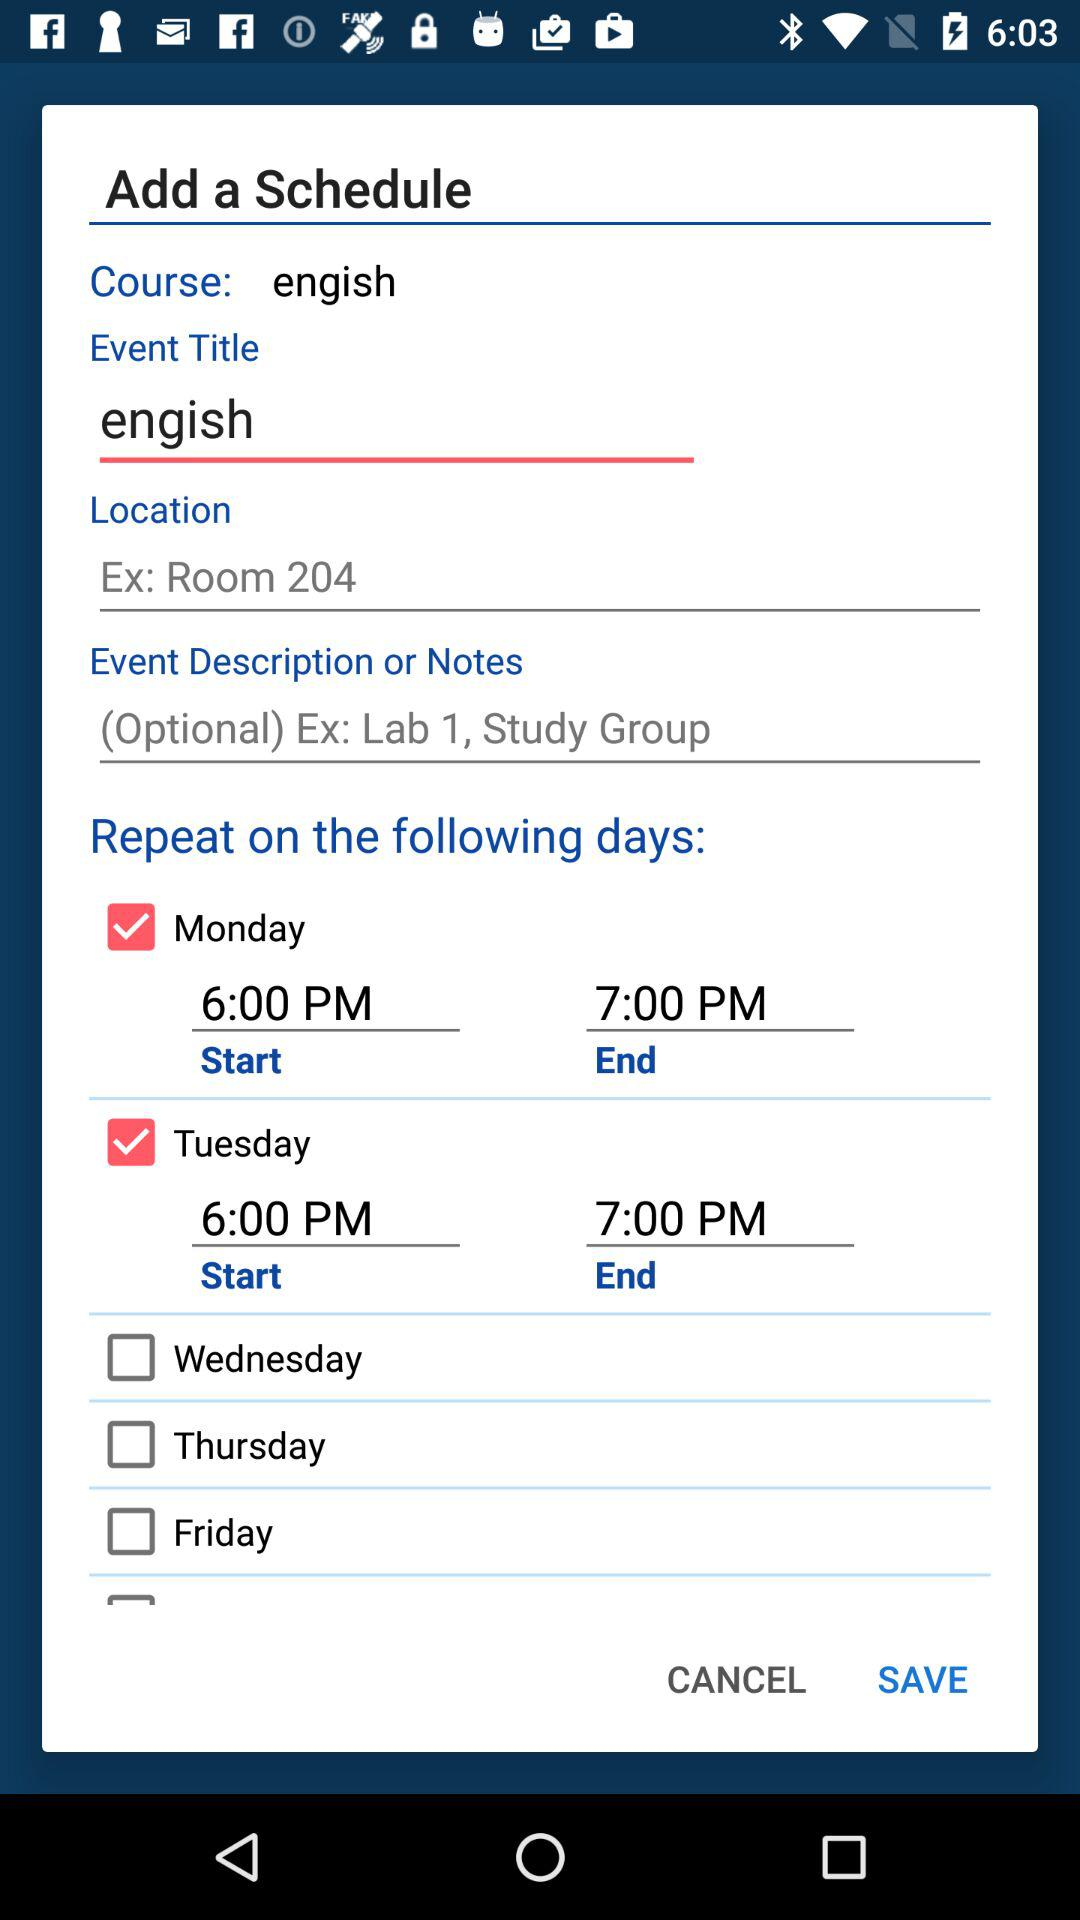What is the scheduled end time for Monday? The scheduled end time for Monday is 7:00 PM. 